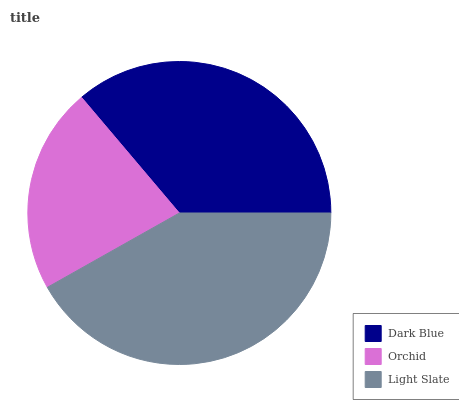Is Orchid the minimum?
Answer yes or no. Yes. Is Light Slate the maximum?
Answer yes or no. Yes. Is Light Slate the minimum?
Answer yes or no. No. Is Orchid the maximum?
Answer yes or no. No. Is Light Slate greater than Orchid?
Answer yes or no. Yes. Is Orchid less than Light Slate?
Answer yes or no. Yes. Is Orchid greater than Light Slate?
Answer yes or no. No. Is Light Slate less than Orchid?
Answer yes or no. No. Is Dark Blue the high median?
Answer yes or no. Yes. Is Dark Blue the low median?
Answer yes or no. Yes. Is Orchid the high median?
Answer yes or no. No. Is Light Slate the low median?
Answer yes or no. No. 